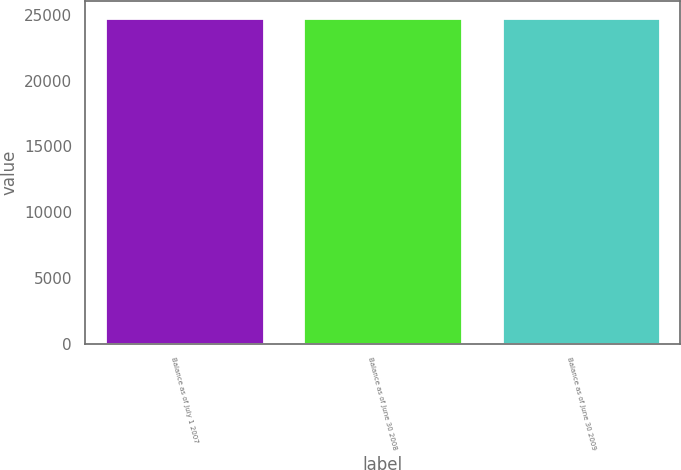<chart> <loc_0><loc_0><loc_500><loc_500><bar_chart><fcel>Balance as of July 1 2007<fcel>Balance as of June 30 2008<fcel>Balance as of June 30 2009<nl><fcel>24798<fcel>24798.1<fcel>24798.2<nl></chart> 